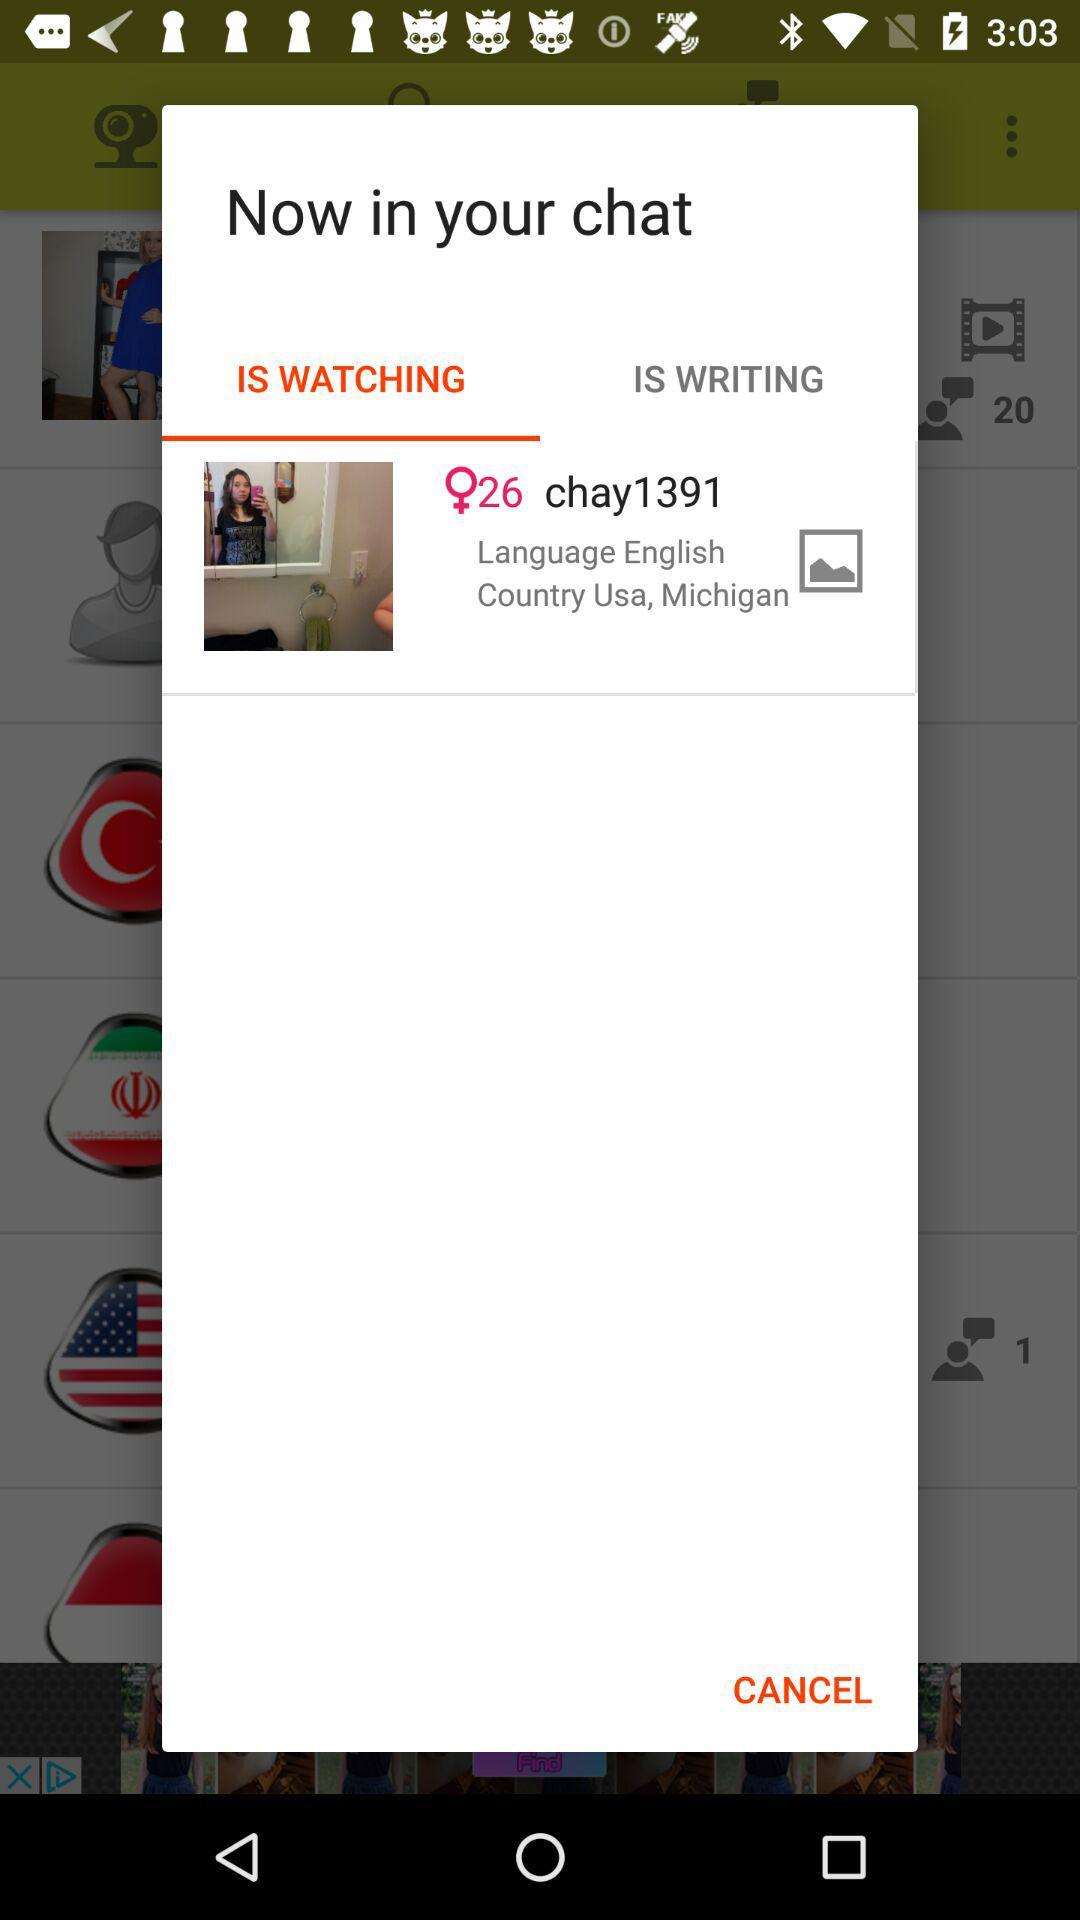What is the language? The language is English. 